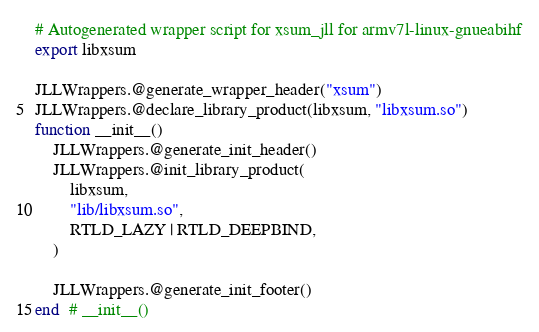<code> <loc_0><loc_0><loc_500><loc_500><_Julia_># Autogenerated wrapper script for xsum_jll for armv7l-linux-gnueabihf
export libxsum

JLLWrappers.@generate_wrapper_header("xsum")
JLLWrappers.@declare_library_product(libxsum, "libxsum.so")
function __init__()
    JLLWrappers.@generate_init_header()
    JLLWrappers.@init_library_product(
        libxsum,
        "lib/libxsum.so",
        RTLD_LAZY | RTLD_DEEPBIND,
    )

    JLLWrappers.@generate_init_footer()
end  # __init__()
</code> 